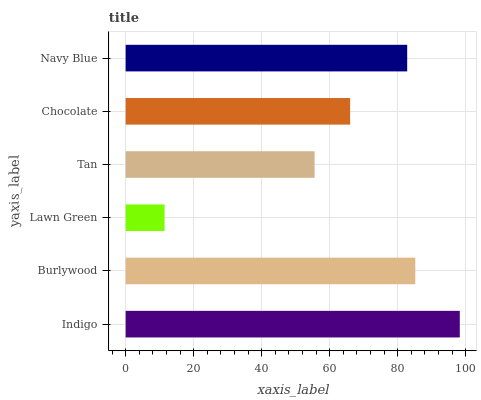Is Lawn Green the minimum?
Answer yes or no. Yes. Is Indigo the maximum?
Answer yes or no. Yes. Is Burlywood the minimum?
Answer yes or no. No. Is Burlywood the maximum?
Answer yes or no. No. Is Indigo greater than Burlywood?
Answer yes or no. Yes. Is Burlywood less than Indigo?
Answer yes or no. Yes. Is Burlywood greater than Indigo?
Answer yes or no. No. Is Indigo less than Burlywood?
Answer yes or no. No. Is Navy Blue the high median?
Answer yes or no. Yes. Is Chocolate the low median?
Answer yes or no. Yes. Is Tan the high median?
Answer yes or no. No. Is Indigo the low median?
Answer yes or no. No. 